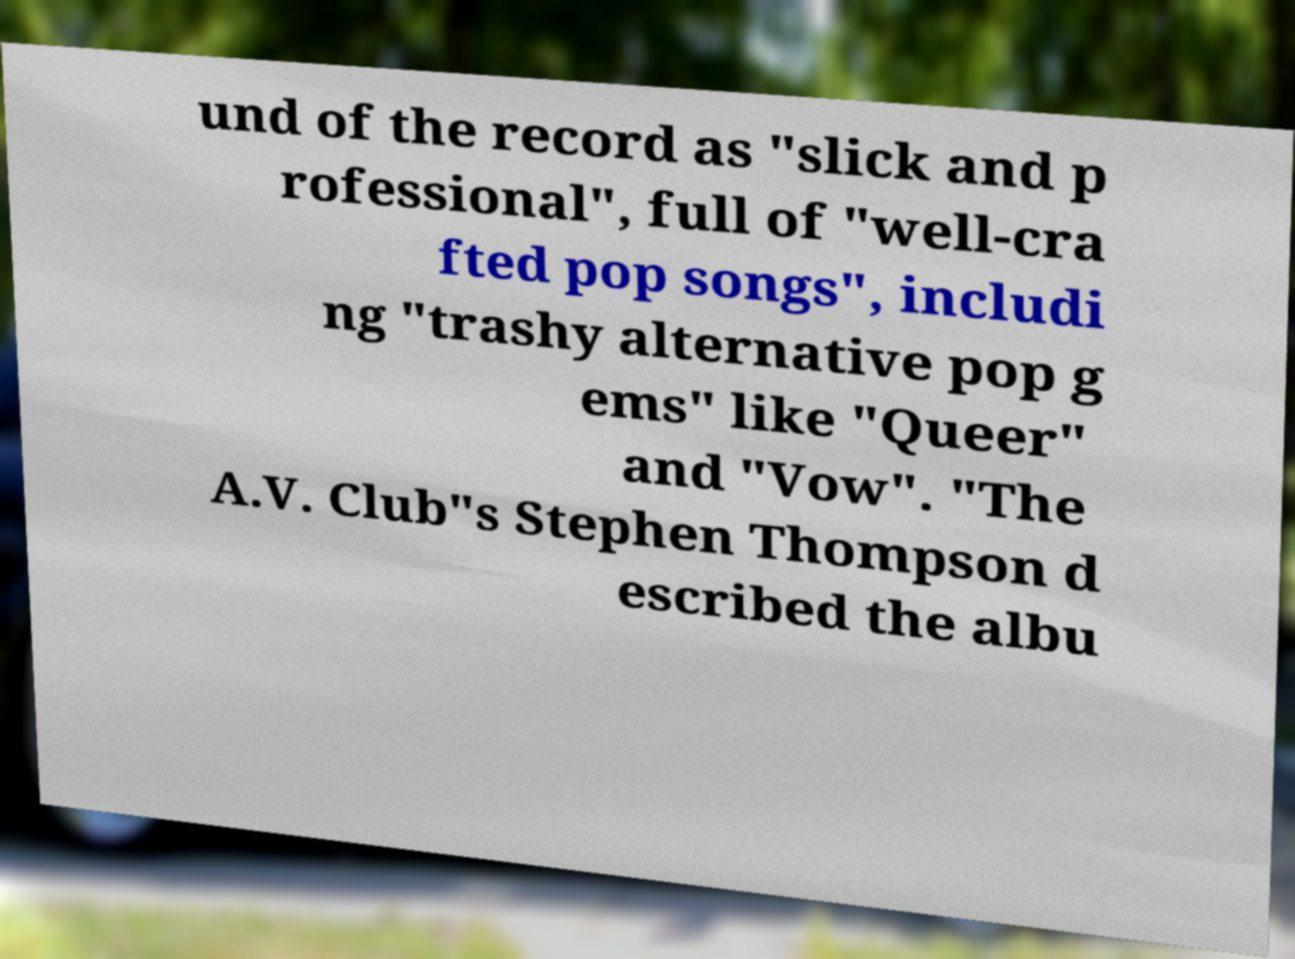Could you extract and type out the text from this image? und of the record as "slick and p rofessional", full of "well-cra fted pop songs", includi ng "trashy alternative pop g ems" like "Queer" and "Vow". "The A.V. Club"s Stephen Thompson d escribed the albu 